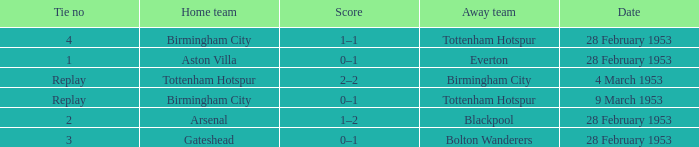Which Home team has a Score of 0–1, and an Away team of tottenham hotspur? Birmingham City. 